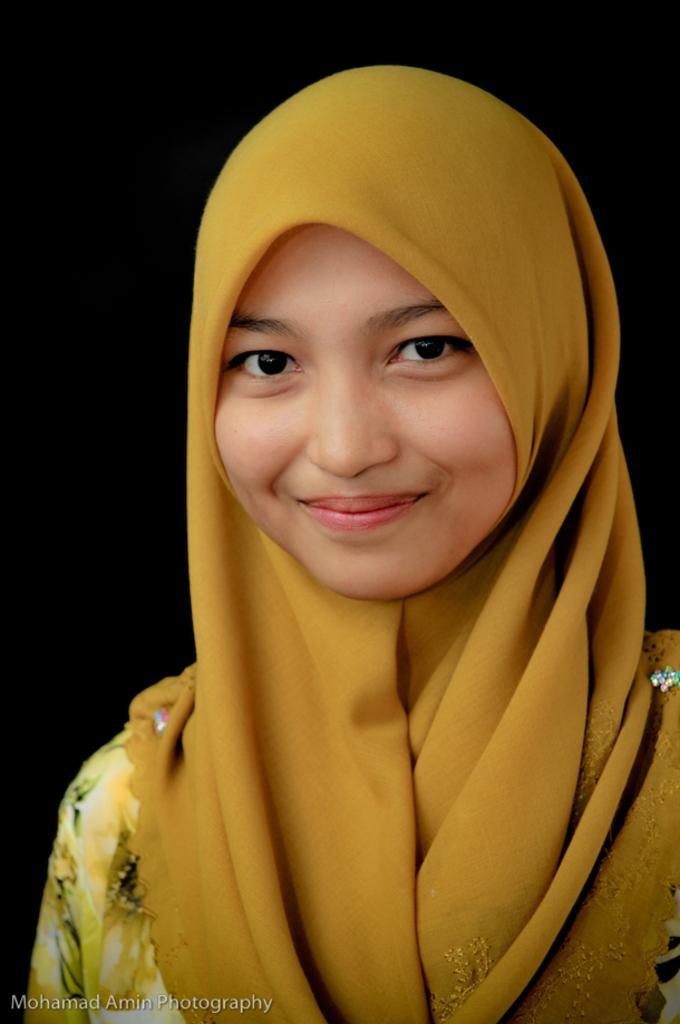Who is present in the image? There is a woman in the image. What is the woman wearing in the image? The woman is wearing a scarf in the image. What can be found at the bottom of the image? There is text at the bottom of the image. How many pies are being sold by the woman in the image? There are no pies present in the image, and the woman is not selling anything. 